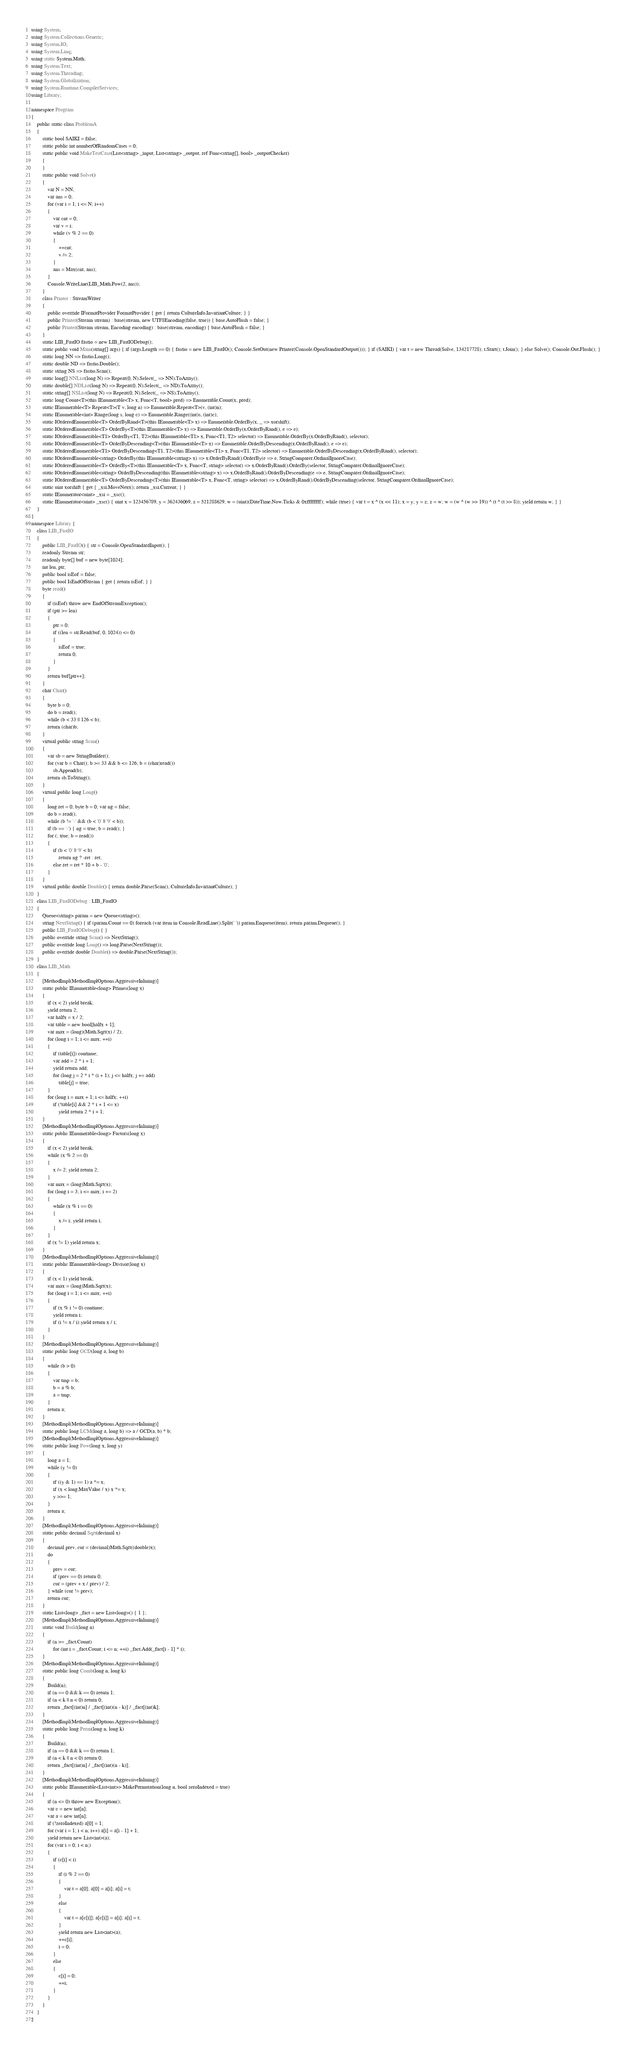<code> <loc_0><loc_0><loc_500><loc_500><_C#_>using System;
using System.Collections.Generic;
using System.IO;
using System.Linq;
using static System.Math;
using System.Text;
using System.Threading;
using System.Globalization;
using System.Runtime.CompilerServices;
using Library;

namespace Program
{
    public static class ProblemA
    {
        static bool SAIKI = false;
        static public int numberOfRandomCases = 0;
        static public void MakeTestCase(List<string> _input, List<string> _output, ref Func<string[], bool> _outputChecker)
        {
        }
        static public void Solve()
        {
            var N = NN;
            var ans = 0;
            for (var i = 1; i <= N; i++)
            {
                var cnt = 0;
                var v = i;
                while (v % 2 == 0)
                {
                    ++cnt;
                    v /= 2;
                }
                ans = Max(cnt, ans);
            }
            Console.WriteLine(LIB_Math.Pow(2, ans));
        }
        class Printer : StreamWriter
        {
            public override IFormatProvider FormatProvider { get { return CultureInfo.InvariantCulture; } }
            public Printer(Stream stream) : base(stream, new UTF8Encoding(false, true)) { base.AutoFlush = false; }
            public Printer(Stream stream, Encoding encoding) : base(stream, encoding) { base.AutoFlush = false; }
        }
        static LIB_FastIO fastio = new LIB_FastIODebug();
        static public void Main(string[] args) { if (args.Length == 0) { fastio = new LIB_FastIO(); Console.SetOut(new Printer(Console.OpenStandardOutput())); } if (SAIKI) { var t = new Thread(Solve, 134217728); t.Start(); t.Join(); } else Solve(); Console.Out.Flush(); }
        static long NN => fastio.Long();
        static double ND => fastio.Double();
        static string NS => fastio.Scan();
        static long[] NNList(long N) => Repeat(0, N).Select(_ => NN).ToArray();
        static double[] NDList(long N) => Repeat(0, N).Select(_ => ND).ToArray();
        static string[] NSList(long N) => Repeat(0, N).Select(_ => NS).ToArray();
        static long Count<T>(this IEnumerable<T> x, Func<T, bool> pred) => Enumerable.Count(x, pred);
        static IEnumerable<T> Repeat<T>(T v, long n) => Enumerable.Repeat<T>(v, (int)n);
        static IEnumerable<int> Range(long s, long c) => Enumerable.Range((int)s, (int)c);
        static IOrderedEnumerable<T> OrderByRand<T>(this IEnumerable<T> x) => Enumerable.OrderBy(x, _ => xorshift);
        static IOrderedEnumerable<T> OrderBy<T>(this IEnumerable<T> x) => Enumerable.OrderBy(x.OrderByRand(), e => e);
        static IOrderedEnumerable<T1> OrderBy<T1, T2>(this IEnumerable<T1> x, Func<T1, T2> selector) => Enumerable.OrderBy(x.OrderByRand(), selector);
        static IOrderedEnumerable<T> OrderByDescending<T>(this IEnumerable<T> x) => Enumerable.OrderByDescending(x.OrderByRand(), e => e);
        static IOrderedEnumerable<T1> OrderByDescending<T1, T2>(this IEnumerable<T1> x, Func<T1, T2> selector) => Enumerable.OrderByDescending(x.OrderByRand(), selector);
        static IOrderedEnumerable<string> OrderBy(this IEnumerable<string> x) => x.OrderByRand().OrderBy(e => e, StringComparer.OrdinalIgnoreCase);
        static IOrderedEnumerable<T> OrderBy<T>(this IEnumerable<T> x, Func<T, string> selector) => x.OrderByRand().OrderBy(selector, StringComparer.OrdinalIgnoreCase);
        static IOrderedEnumerable<string> OrderByDescending(this IEnumerable<string> x) => x.OrderByRand().OrderByDescending(e => e, StringComparer.OrdinalIgnoreCase);
        static IOrderedEnumerable<T> OrderByDescending<T>(this IEnumerable<T> x, Func<T, string> selector) => x.OrderByRand().OrderByDescending(selector, StringComparer.OrdinalIgnoreCase);
        static uint xorshift { get { _xsi.MoveNext(); return _xsi.Current; } }
        static IEnumerator<uint> _xsi = _xsc();
        static IEnumerator<uint> _xsc() { uint x = 123456789, y = 362436069, z = 521288629, w = (uint)(DateTime.Now.Ticks & 0xffffffff); while (true) { var t = x ^ (x << 11); x = y; y = z; z = w; w = (w ^ (w >> 19)) ^ (t ^ (t >> 8)); yield return w; } }
    }
}
namespace Library {
    class LIB_FastIO
    {
        public LIB_FastIO() { str = Console.OpenStandardInput(); }
        readonly Stream str;
        readonly byte[] buf = new byte[1024];
        int len, ptr;
        public bool isEof = false;
        public bool IsEndOfStream { get { return isEof; } }
        byte read()
        {
            if (isEof) throw new EndOfStreamException();
            if (ptr >= len)
            {
                ptr = 0;
                if ((len = str.Read(buf, 0, 1024)) <= 0)
                {
                    isEof = true;
                    return 0;
                }
            }
            return buf[ptr++];
        }
        char Char()
        {
            byte b = 0;
            do b = read();
            while (b < 33 || 126 < b);
            return (char)b;
        }
        virtual public string Scan()
        {
            var sb = new StringBuilder();
            for (var b = Char(); b >= 33 && b <= 126; b = (char)read())
                sb.Append(b);
            return sb.ToString();
        }
        virtual public long Long()
        {
            long ret = 0; byte b = 0; var ng = false;
            do b = read();
            while (b != '-' && (b < '0' || '9' < b));
            if (b == '-') { ng = true; b = read(); }
            for (; true; b = read())
            {
                if (b < '0' || '9' < b)
                    return ng ? -ret : ret;
                else ret = ret * 10 + b - '0';
            }
        }
        virtual public double Double() { return double.Parse(Scan(), CultureInfo.InvariantCulture); }
    }
    class LIB_FastIODebug : LIB_FastIO
    {
        Queue<string> param = new Queue<string>();
        string NextString() { if (param.Count == 0) foreach (var item in Console.ReadLine().Split(' ')) param.Enqueue(item); return param.Dequeue(); }
        public LIB_FastIODebug() { }
        public override string Scan() => NextString();
        public override long Long() => long.Parse(NextString());
        public override double Double() => double.Parse(NextString());
    }
    class LIB_Math
    {
        [MethodImpl(MethodImplOptions.AggressiveInlining)]
        static public IEnumerable<long> Primes(long x)
        {
            if (x < 2) yield break;
            yield return 2;
            var halfx = x / 2;
            var table = new bool[halfx + 1];
            var max = (long)(Math.Sqrt(x) / 2);
            for (long i = 1; i <= max; ++i)
            {
                if (table[i]) continue;
                var add = 2 * i + 1;
                yield return add;
                for (long j = 2 * i * (i + 1); j <= halfx; j += add)
                    table[j] = true;
            }
            for (long i = max + 1; i <= halfx; ++i)
                if (!table[i] && 2 * i + 1 <= x)
                    yield return 2 * i + 1;
        }
        [MethodImpl(MethodImplOptions.AggressiveInlining)]
        static public IEnumerable<long> Factors(long x)
        {
            if (x < 2) yield break;
            while (x % 2 == 0)
            {
                x /= 2; yield return 2;
            }
            var max = (long)Math.Sqrt(x);
            for (long i = 3; i <= max; i += 2)
            {
                while (x % i == 0)
                {
                    x /= i; yield return i;
                }
            }
            if (x != 1) yield return x;
        }
        [MethodImpl(MethodImplOptions.AggressiveInlining)]
        static public IEnumerable<long> Divisor(long x)
        {
            if (x < 1) yield break;
            var max = (long)Math.Sqrt(x);
            for (long i = 1; i <= max; ++i)
            {
                if (x % i != 0) continue;
                yield return i;
                if (i != x / i) yield return x / i;
            }
        }
        [MethodImpl(MethodImplOptions.AggressiveInlining)]
        static public long GCD(long a, long b)
        {
            while (b > 0)
            {
                var tmp = b;
                b = a % b;
                a = tmp;
            }
            return a;
        }
        [MethodImpl(MethodImplOptions.AggressiveInlining)]
        static public long LCM(long a, long b) => a / GCD(a, b) * b;
        [MethodImpl(MethodImplOptions.AggressiveInlining)]
        static public long Pow(long x, long y)
        {
            long a = 1;
            while (y != 0)
            {
                if ((y & 1) == 1) a *= x;
                if (x < long.MaxValue / x) x *= x;
                y >>= 1;
            }
            return a;
        }
        [MethodImpl(MethodImplOptions.AggressiveInlining)]
        static public decimal Sqrt(decimal x)
        {
            decimal prev, cur = (decimal)Math.Sqrt((double)x);
            do
            {
                prev = cur;
                if (prev == 0) return 0;
                cur = (prev + x / prev) / 2;
            } while (cur != prev);
            return cur;
        }
        static List<long> _fact = new List<long>() { 1 };
        [MethodImpl(MethodImplOptions.AggressiveInlining)]
        static void Build(long n)
        {
            if (n >= _fact.Count)
                for (int i = _fact.Count; i <= n; ++i) _fact.Add(_fact[i - 1] * i);
        }
        [MethodImpl(MethodImplOptions.AggressiveInlining)]
        static public long Comb(long n, long k)
        {
            Build(n);
            if (n == 0 && k == 0) return 1;
            if (n < k || n < 0) return 0;
            return _fact[(int)n] / _fact[(int)(n - k)] / _fact[(int)k];
        }
        [MethodImpl(MethodImplOptions.AggressiveInlining)]
        static public long Perm(long n, long k)
        {
            Build(n);
            if (n == 0 && k == 0) return 1;
            if (n < k || n < 0) return 0;
            return _fact[(int)n] / _fact[(int)(n - k)];
        }
        [MethodImpl(MethodImplOptions.AggressiveInlining)]
        static public IEnumerable<List<int>> MakePermutation(long n, bool zeroIndexed = true)
        {
            if (n <= 0) throw new Exception();
            var c = new int[n];
            var a = new int[n];
            if (!zeroIndexed) a[0] = 1;
            for (var i = 1; i < n; i++) a[i] = a[i - 1] + 1;
            yield return new List<int>(a);
            for (var i = 0; i < n;)
            {
                if (c[i] < i)
                {
                    if (i % 2 == 0)
                    {
                        var t = a[0]; a[0] = a[i]; a[i] = t;
                    }
                    else
                    {
                        var t = a[c[i]]; a[c[i]] = a[i]; a[i] = t;
                    }
                    yield return new List<int>(a);
                    ++c[i];
                    i = 0;
                }
                else
                {
                    c[i] = 0;
                    ++i;
                }
            }
        }
    }
}
</code> 